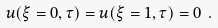<formula> <loc_0><loc_0><loc_500><loc_500>u ( \xi = 0 , \tau ) = u ( \xi = 1 , \tau ) = 0 \ .</formula> 